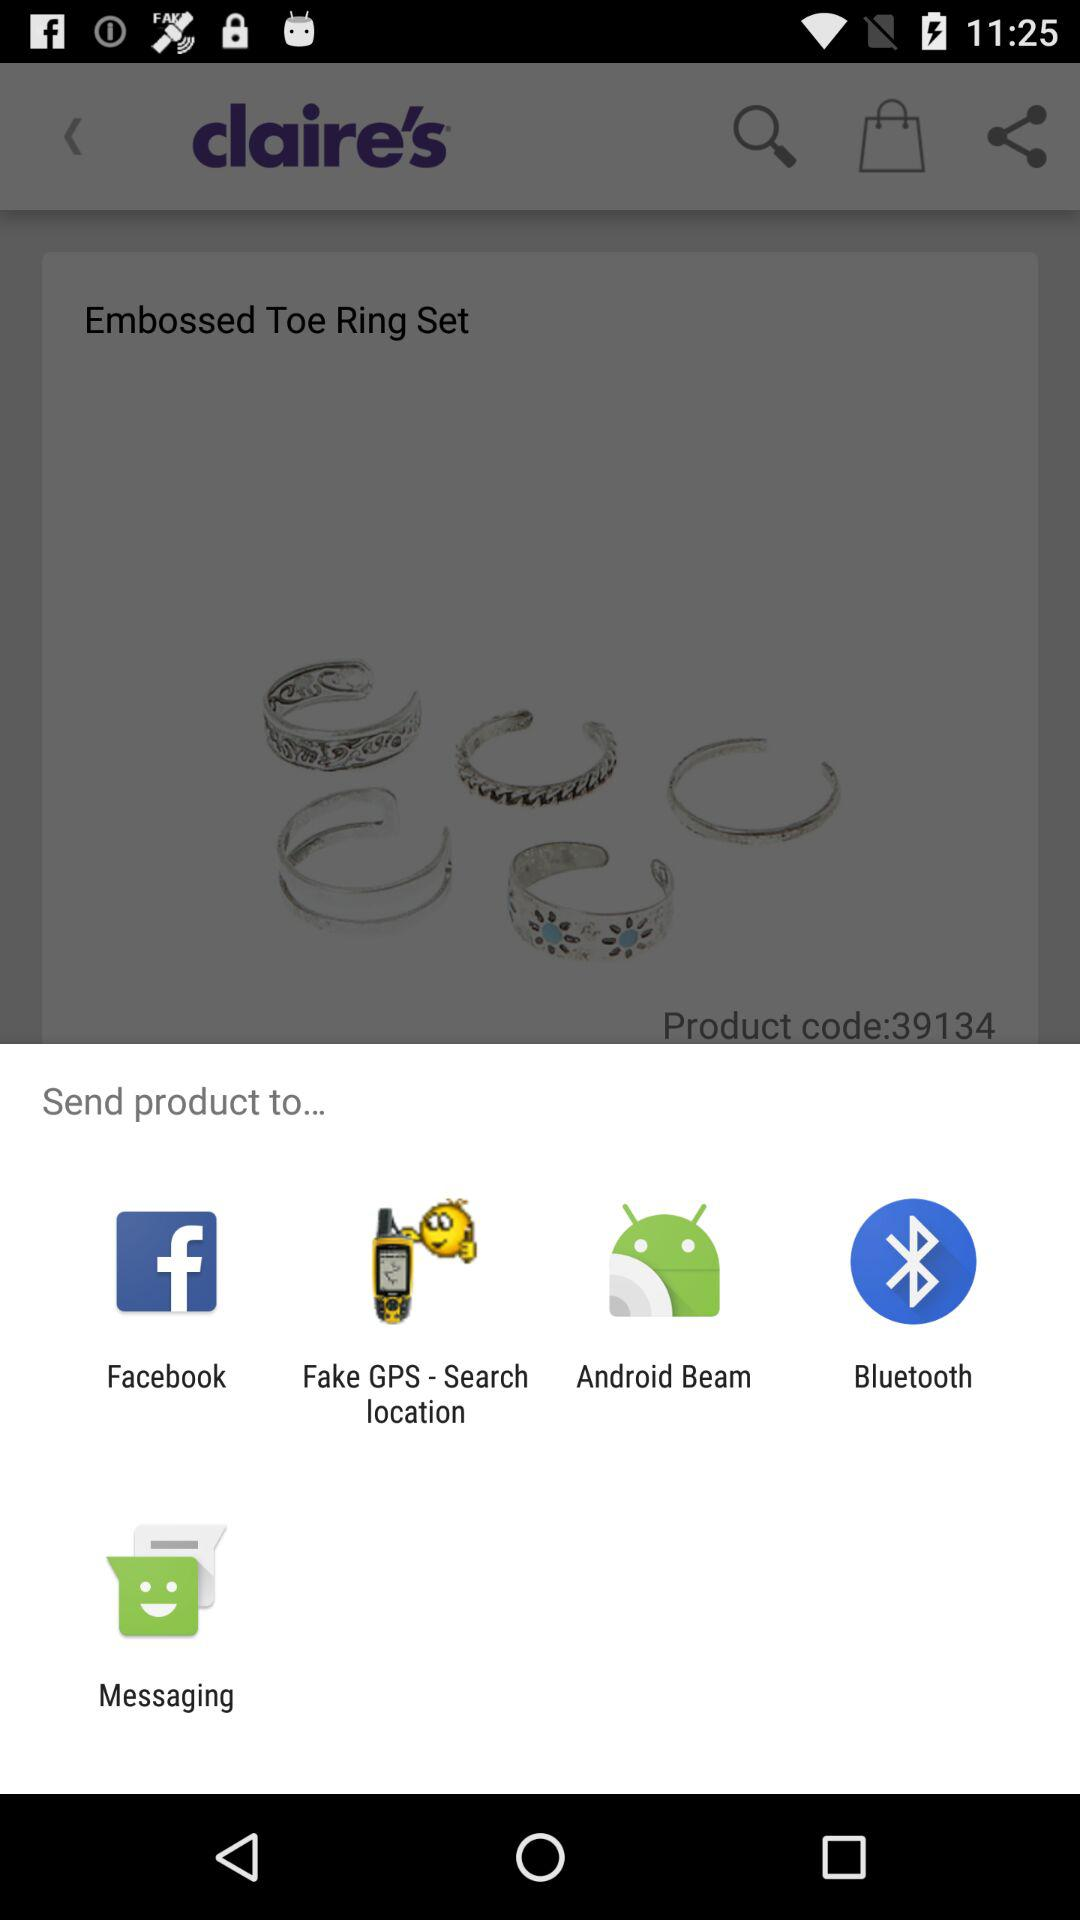Through what app can we share it? You can share it through "Facebook", "Fake GPS - Search location", "Android Beam", "Bluetooth", and "Messaging". 